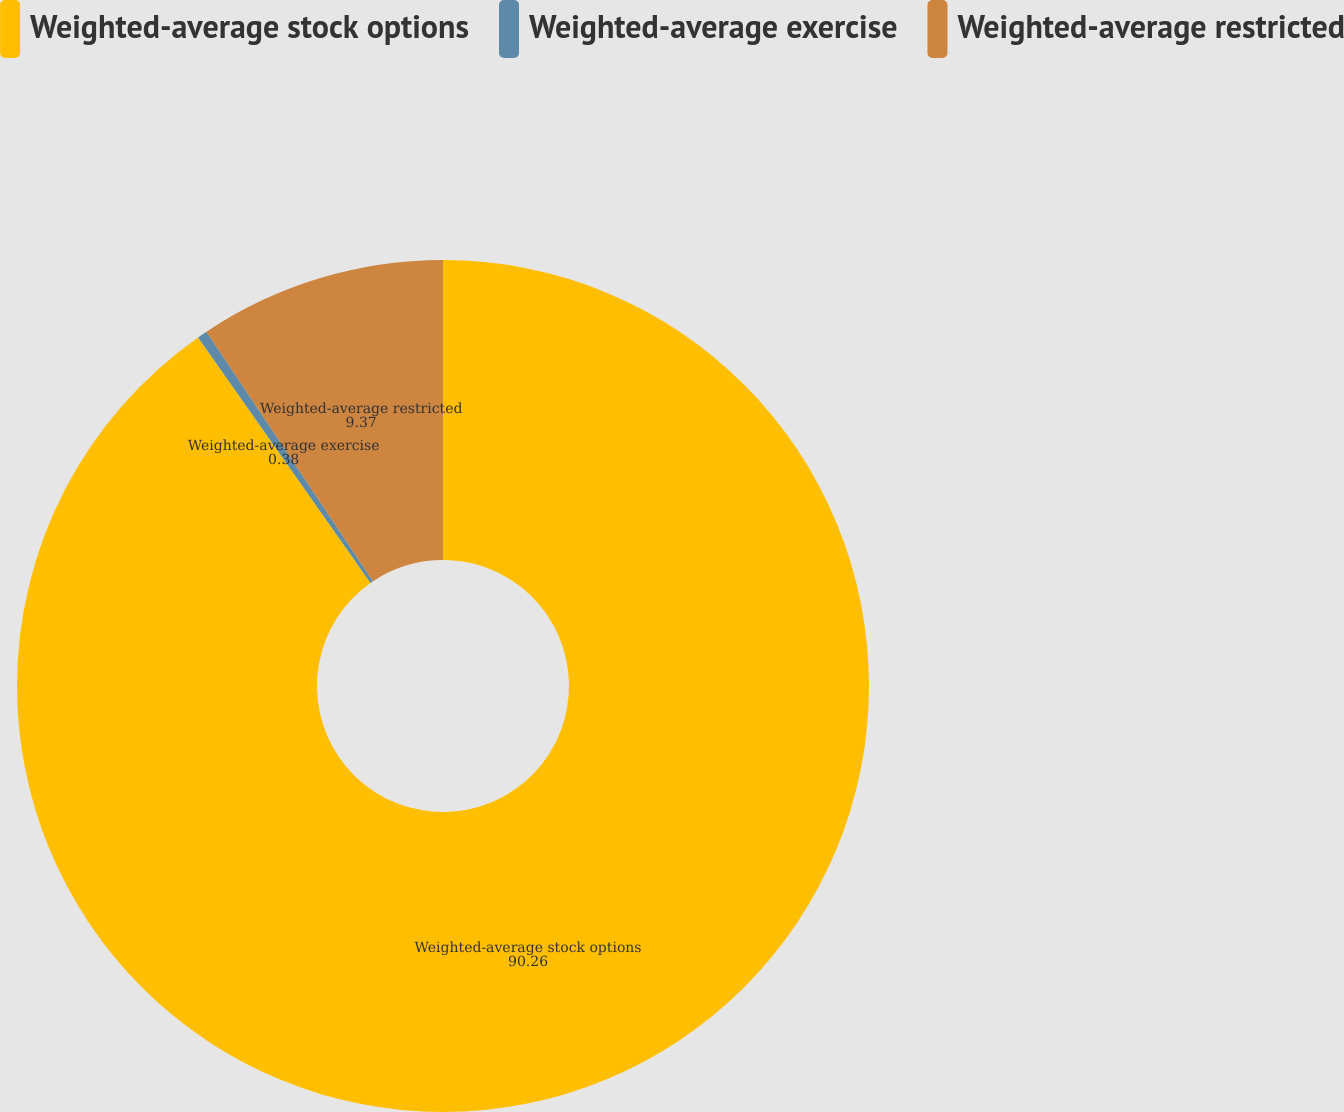Convert chart to OTSL. <chart><loc_0><loc_0><loc_500><loc_500><pie_chart><fcel>Weighted-average stock options<fcel>Weighted-average exercise<fcel>Weighted-average restricted<nl><fcel>90.26%<fcel>0.38%<fcel>9.37%<nl></chart> 